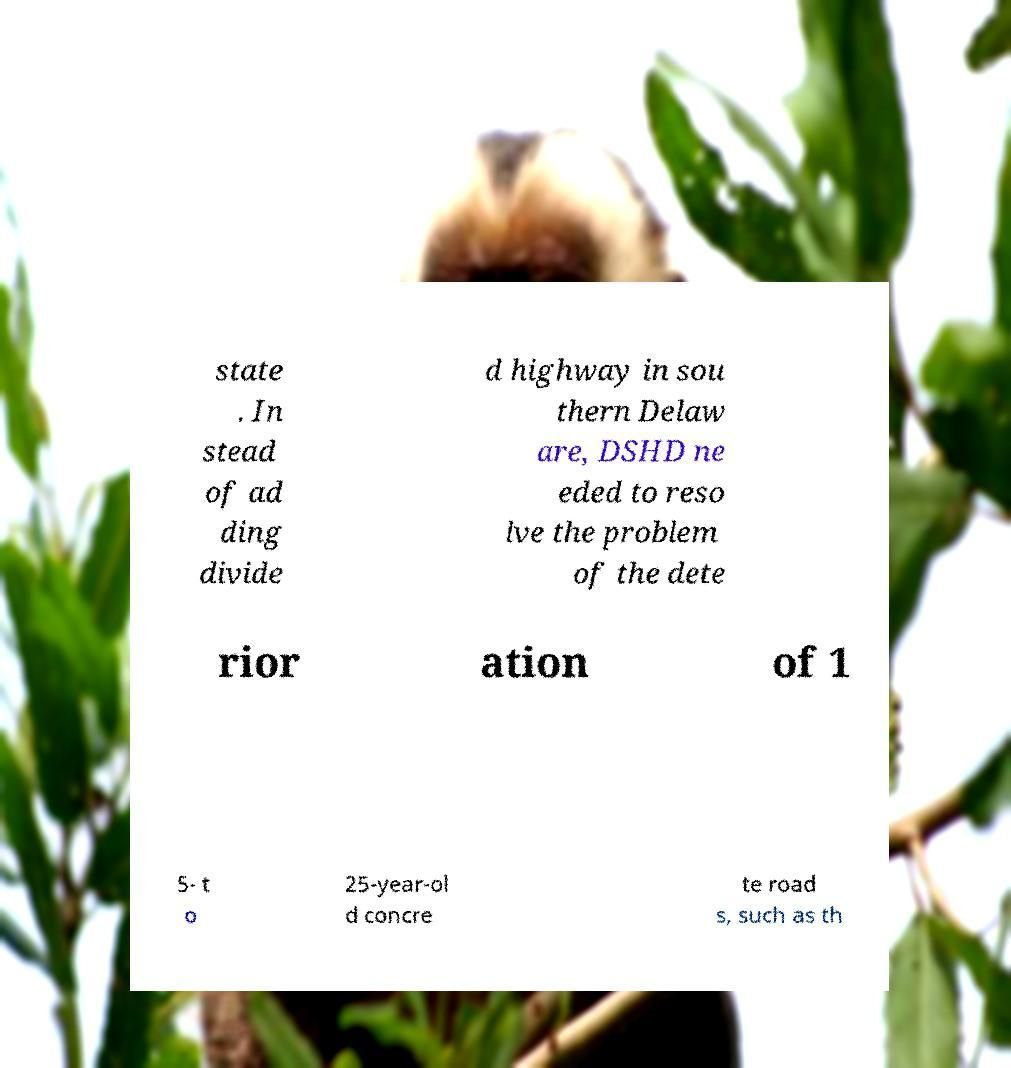For documentation purposes, I need the text within this image transcribed. Could you provide that? state . In stead of ad ding divide d highway in sou thern Delaw are, DSHD ne eded to reso lve the problem of the dete rior ation of 1 5- t o 25-year-ol d concre te road s, such as th 